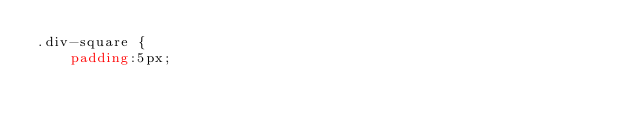Convert code to text. <code><loc_0><loc_0><loc_500><loc_500><_CSS_>.div-square {
    padding:5px;</code> 